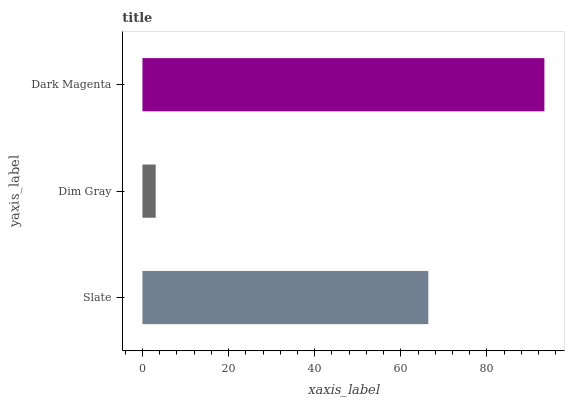Is Dim Gray the minimum?
Answer yes or no. Yes. Is Dark Magenta the maximum?
Answer yes or no. Yes. Is Dark Magenta the minimum?
Answer yes or no. No. Is Dim Gray the maximum?
Answer yes or no. No. Is Dark Magenta greater than Dim Gray?
Answer yes or no. Yes. Is Dim Gray less than Dark Magenta?
Answer yes or no. Yes. Is Dim Gray greater than Dark Magenta?
Answer yes or no. No. Is Dark Magenta less than Dim Gray?
Answer yes or no. No. Is Slate the high median?
Answer yes or no. Yes. Is Slate the low median?
Answer yes or no. Yes. Is Dark Magenta the high median?
Answer yes or no. No. Is Dark Magenta the low median?
Answer yes or no. No. 